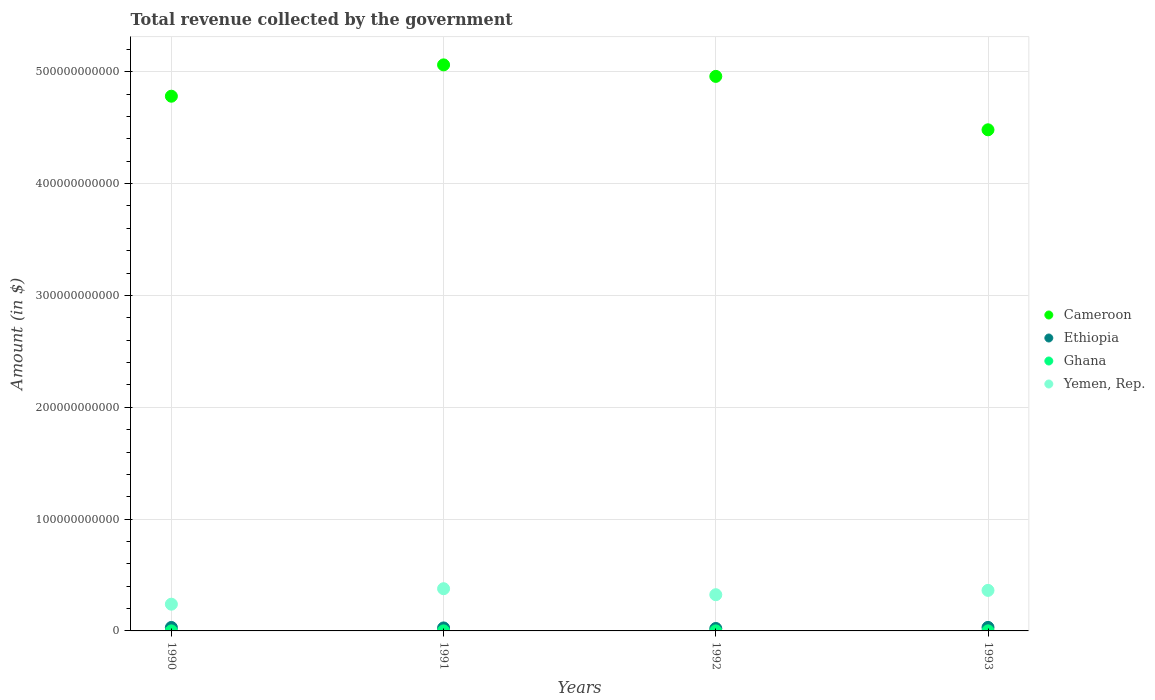How many different coloured dotlines are there?
Your response must be concise. 4. Is the number of dotlines equal to the number of legend labels?
Provide a succinct answer. Yes. What is the total revenue collected by the government in Ethiopia in 1993?
Keep it short and to the point. 3.15e+09. Across all years, what is the maximum total revenue collected by the government in Ethiopia?
Your answer should be very brief. 3.15e+09. Across all years, what is the minimum total revenue collected by the government in Ethiopia?
Provide a succinct answer. 2.18e+09. In which year was the total revenue collected by the government in Yemen, Rep. minimum?
Make the answer very short. 1990. What is the total total revenue collected by the government in Ghana in the graph?
Your answer should be compact. 1.58e+08. What is the difference between the total revenue collected by the government in Ethiopia in 1992 and that in 1993?
Make the answer very short. -9.67e+08. What is the difference between the total revenue collected by the government in Yemen, Rep. in 1991 and the total revenue collected by the government in Ethiopia in 1992?
Provide a succinct answer. 3.56e+1. What is the average total revenue collected by the government in Cameroon per year?
Make the answer very short. 4.82e+11. In the year 1992, what is the difference between the total revenue collected by the government in Cameroon and total revenue collected by the government in Ethiopia?
Your answer should be compact. 4.94e+11. What is the ratio of the total revenue collected by the government in Yemen, Rep. in 1990 to that in 1992?
Give a very brief answer. 0.74. What is the difference between the highest and the second highest total revenue collected by the government in Ethiopia?
Provide a succinct answer. 5.94e+07. What is the difference between the highest and the lowest total revenue collected by the government in Cameroon?
Offer a very short reply. 5.81e+1. In how many years, is the total revenue collected by the government in Cameroon greater than the average total revenue collected by the government in Cameroon taken over all years?
Make the answer very short. 2. Is the sum of the total revenue collected by the government in Yemen, Rep. in 1992 and 1993 greater than the maximum total revenue collected by the government in Ghana across all years?
Offer a terse response. Yes. Is it the case that in every year, the sum of the total revenue collected by the government in Ethiopia and total revenue collected by the government in Yemen, Rep.  is greater than the total revenue collected by the government in Cameroon?
Make the answer very short. No. Is the total revenue collected by the government in Ghana strictly less than the total revenue collected by the government in Yemen, Rep. over the years?
Your answer should be very brief. Yes. What is the difference between two consecutive major ticks on the Y-axis?
Provide a succinct answer. 1.00e+11. Are the values on the major ticks of Y-axis written in scientific E-notation?
Offer a very short reply. No. Does the graph contain any zero values?
Offer a terse response. No. How many legend labels are there?
Offer a very short reply. 4. What is the title of the graph?
Your answer should be very brief. Total revenue collected by the government. Does "Middle East & North Africa (all income levels)" appear as one of the legend labels in the graph?
Provide a short and direct response. No. What is the label or title of the X-axis?
Offer a very short reply. Years. What is the label or title of the Y-axis?
Your answer should be compact. Amount (in $). What is the Amount (in $) in Cameroon in 1990?
Keep it short and to the point. 4.78e+11. What is the Amount (in $) in Ethiopia in 1990?
Ensure brevity in your answer.  3.09e+09. What is the Amount (in $) in Ghana in 1990?
Offer a terse response. 2.40e+07. What is the Amount (in $) in Yemen, Rep. in 1990?
Your response must be concise. 2.39e+1. What is the Amount (in $) of Cameroon in 1991?
Provide a short and direct response. 5.06e+11. What is the Amount (in $) of Ethiopia in 1991?
Give a very brief answer. 2.67e+09. What is the Amount (in $) of Ghana in 1991?
Offer a very short reply. 3.54e+07. What is the Amount (in $) in Yemen, Rep. in 1991?
Offer a very short reply. 3.77e+1. What is the Amount (in $) of Cameroon in 1992?
Keep it short and to the point. 4.96e+11. What is the Amount (in $) of Ethiopia in 1992?
Your answer should be compact. 2.18e+09. What is the Amount (in $) in Ghana in 1992?
Offer a very short reply. 3.34e+07. What is the Amount (in $) in Yemen, Rep. in 1992?
Keep it short and to the point. 3.24e+1. What is the Amount (in $) of Cameroon in 1993?
Provide a succinct answer. 4.48e+11. What is the Amount (in $) in Ethiopia in 1993?
Give a very brief answer. 3.15e+09. What is the Amount (in $) in Ghana in 1993?
Offer a very short reply. 6.58e+07. What is the Amount (in $) in Yemen, Rep. in 1993?
Provide a succinct answer. 3.63e+1. Across all years, what is the maximum Amount (in $) of Cameroon?
Keep it short and to the point. 5.06e+11. Across all years, what is the maximum Amount (in $) of Ethiopia?
Keep it short and to the point. 3.15e+09. Across all years, what is the maximum Amount (in $) of Ghana?
Your answer should be compact. 6.58e+07. Across all years, what is the maximum Amount (in $) in Yemen, Rep.?
Your response must be concise. 3.77e+1. Across all years, what is the minimum Amount (in $) in Cameroon?
Give a very brief answer. 4.48e+11. Across all years, what is the minimum Amount (in $) of Ethiopia?
Provide a succinct answer. 2.18e+09. Across all years, what is the minimum Amount (in $) of Ghana?
Offer a terse response. 2.40e+07. Across all years, what is the minimum Amount (in $) in Yemen, Rep.?
Provide a short and direct response. 2.39e+1. What is the total Amount (in $) in Cameroon in the graph?
Provide a short and direct response. 1.93e+12. What is the total Amount (in $) of Ethiopia in the graph?
Ensure brevity in your answer.  1.11e+1. What is the total Amount (in $) of Ghana in the graph?
Give a very brief answer. 1.58e+08. What is the total Amount (in $) of Yemen, Rep. in the graph?
Offer a very short reply. 1.30e+11. What is the difference between the Amount (in $) in Cameroon in 1990 and that in 1991?
Ensure brevity in your answer.  -2.80e+1. What is the difference between the Amount (in $) in Ethiopia in 1990 and that in 1991?
Provide a short and direct response. 4.22e+08. What is the difference between the Amount (in $) of Ghana in 1990 and that in 1991?
Offer a terse response. -1.15e+07. What is the difference between the Amount (in $) of Yemen, Rep. in 1990 and that in 1991?
Give a very brief answer. -1.38e+1. What is the difference between the Amount (in $) in Cameroon in 1990 and that in 1992?
Offer a very short reply. -1.77e+1. What is the difference between the Amount (in $) of Ethiopia in 1990 and that in 1992?
Your response must be concise. 9.08e+08. What is the difference between the Amount (in $) of Ghana in 1990 and that in 1992?
Give a very brief answer. -9.41e+06. What is the difference between the Amount (in $) in Yemen, Rep. in 1990 and that in 1992?
Your response must be concise. -8.48e+09. What is the difference between the Amount (in $) in Cameroon in 1990 and that in 1993?
Offer a terse response. 3.00e+1. What is the difference between the Amount (in $) of Ethiopia in 1990 and that in 1993?
Give a very brief answer. -5.94e+07. What is the difference between the Amount (in $) in Ghana in 1990 and that in 1993?
Your answer should be compact. -4.18e+07. What is the difference between the Amount (in $) in Yemen, Rep. in 1990 and that in 1993?
Ensure brevity in your answer.  -1.23e+1. What is the difference between the Amount (in $) of Cameroon in 1991 and that in 1992?
Your answer should be compact. 1.03e+1. What is the difference between the Amount (in $) of Ethiopia in 1991 and that in 1992?
Make the answer very short. 4.86e+08. What is the difference between the Amount (in $) of Ghana in 1991 and that in 1992?
Provide a succinct answer. 2.08e+06. What is the difference between the Amount (in $) of Yemen, Rep. in 1991 and that in 1992?
Ensure brevity in your answer.  5.37e+09. What is the difference between the Amount (in $) of Cameroon in 1991 and that in 1993?
Make the answer very short. 5.81e+1. What is the difference between the Amount (in $) of Ethiopia in 1991 and that in 1993?
Keep it short and to the point. -4.81e+08. What is the difference between the Amount (in $) in Ghana in 1991 and that in 1993?
Your response must be concise. -3.03e+07. What is the difference between the Amount (in $) in Yemen, Rep. in 1991 and that in 1993?
Offer a terse response. 1.50e+09. What is the difference between the Amount (in $) of Cameroon in 1992 and that in 1993?
Offer a terse response. 4.78e+1. What is the difference between the Amount (in $) of Ethiopia in 1992 and that in 1993?
Keep it short and to the point. -9.67e+08. What is the difference between the Amount (in $) in Ghana in 1992 and that in 1993?
Offer a terse response. -3.24e+07. What is the difference between the Amount (in $) of Yemen, Rep. in 1992 and that in 1993?
Your answer should be compact. -3.87e+09. What is the difference between the Amount (in $) in Cameroon in 1990 and the Amount (in $) in Ethiopia in 1991?
Give a very brief answer. 4.76e+11. What is the difference between the Amount (in $) in Cameroon in 1990 and the Amount (in $) in Ghana in 1991?
Provide a short and direct response. 4.78e+11. What is the difference between the Amount (in $) in Cameroon in 1990 and the Amount (in $) in Yemen, Rep. in 1991?
Provide a short and direct response. 4.40e+11. What is the difference between the Amount (in $) in Ethiopia in 1990 and the Amount (in $) in Ghana in 1991?
Offer a terse response. 3.06e+09. What is the difference between the Amount (in $) in Ethiopia in 1990 and the Amount (in $) in Yemen, Rep. in 1991?
Offer a very short reply. -3.47e+1. What is the difference between the Amount (in $) of Ghana in 1990 and the Amount (in $) of Yemen, Rep. in 1991?
Provide a succinct answer. -3.77e+1. What is the difference between the Amount (in $) in Cameroon in 1990 and the Amount (in $) in Ethiopia in 1992?
Offer a terse response. 4.76e+11. What is the difference between the Amount (in $) in Cameroon in 1990 and the Amount (in $) in Ghana in 1992?
Make the answer very short. 4.78e+11. What is the difference between the Amount (in $) in Cameroon in 1990 and the Amount (in $) in Yemen, Rep. in 1992?
Ensure brevity in your answer.  4.46e+11. What is the difference between the Amount (in $) of Ethiopia in 1990 and the Amount (in $) of Ghana in 1992?
Ensure brevity in your answer.  3.06e+09. What is the difference between the Amount (in $) in Ethiopia in 1990 and the Amount (in $) in Yemen, Rep. in 1992?
Provide a short and direct response. -2.93e+1. What is the difference between the Amount (in $) in Ghana in 1990 and the Amount (in $) in Yemen, Rep. in 1992?
Ensure brevity in your answer.  -3.24e+1. What is the difference between the Amount (in $) in Cameroon in 1990 and the Amount (in $) in Ethiopia in 1993?
Your answer should be very brief. 4.75e+11. What is the difference between the Amount (in $) in Cameroon in 1990 and the Amount (in $) in Ghana in 1993?
Give a very brief answer. 4.78e+11. What is the difference between the Amount (in $) in Cameroon in 1990 and the Amount (in $) in Yemen, Rep. in 1993?
Offer a very short reply. 4.42e+11. What is the difference between the Amount (in $) in Ethiopia in 1990 and the Amount (in $) in Ghana in 1993?
Make the answer very short. 3.03e+09. What is the difference between the Amount (in $) of Ethiopia in 1990 and the Amount (in $) of Yemen, Rep. in 1993?
Your answer should be very brief. -3.32e+1. What is the difference between the Amount (in $) in Ghana in 1990 and the Amount (in $) in Yemen, Rep. in 1993?
Keep it short and to the point. -3.62e+1. What is the difference between the Amount (in $) in Cameroon in 1991 and the Amount (in $) in Ethiopia in 1992?
Provide a succinct answer. 5.04e+11. What is the difference between the Amount (in $) of Cameroon in 1991 and the Amount (in $) of Ghana in 1992?
Your answer should be compact. 5.06e+11. What is the difference between the Amount (in $) of Cameroon in 1991 and the Amount (in $) of Yemen, Rep. in 1992?
Give a very brief answer. 4.74e+11. What is the difference between the Amount (in $) in Ethiopia in 1991 and the Amount (in $) in Ghana in 1992?
Make the answer very short. 2.64e+09. What is the difference between the Amount (in $) of Ethiopia in 1991 and the Amount (in $) of Yemen, Rep. in 1992?
Offer a very short reply. -2.97e+1. What is the difference between the Amount (in $) in Ghana in 1991 and the Amount (in $) in Yemen, Rep. in 1992?
Ensure brevity in your answer.  -3.23e+1. What is the difference between the Amount (in $) of Cameroon in 1991 and the Amount (in $) of Ethiopia in 1993?
Offer a terse response. 5.03e+11. What is the difference between the Amount (in $) in Cameroon in 1991 and the Amount (in $) in Ghana in 1993?
Your response must be concise. 5.06e+11. What is the difference between the Amount (in $) in Cameroon in 1991 and the Amount (in $) in Yemen, Rep. in 1993?
Provide a short and direct response. 4.70e+11. What is the difference between the Amount (in $) of Ethiopia in 1991 and the Amount (in $) of Ghana in 1993?
Your response must be concise. 2.60e+09. What is the difference between the Amount (in $) of Ethiopia in 1991 and the Amount (in $) of Yemen, Rep. in 1993?
Provide a short and direct response. -3.36e+1. What is the difference between the Amount (in $) in Ghana in 1991 and the Amount (in $) in Yemen, Rep. in 1993?
Provide a short and direct response. -3.62e+1. What is the difference between the Amount (in $) in Cameroon in 1992 and the Amount (in $) in Ethiopia in 1993?
Offer a terse response. 4.93e+11. What is the difference between the Amount (in $) in Cameroon in 1992 and the Amount (in $) in Ghana in 1993?
Offer a very short reply. 4.96e+11. What is the difference between the Amount (in $) of Cameroon in 1992 and the Amount (in $) of Yemen, Rep. in 1993?
Your answer should be very brief. 4.60e+11. What is the difference between the Amount (in $) in Ethiopia in 1992 and the Amount (in $) in Ghana in 1993?
Provide a short and direct response. 2.12e+09. What is the difference between the Amount (in $) in Ethiopia in 1992 and the Amount (in $) in Yemen, Rep. in 1993?
Your answer should be very brief. -3.41e+1. What is the difference between the Amount (in $) in Ghana in 1992 and the Amount (in $) in Yemen, Rep. in 1993?
Provide a short and direct response. -3.62e+1. What is the average Amount (in $) of Cameroon per year?
Provide a succinct answer. 4.82e+11. What is the average Amount (in $) of Ethiopia per year?
Offer a terse response. 2.77e+09. What is the average Amount (in $) in Ghana per year?
Your answer should be compact. 3.96e+07. What is the average Amount (in $) of Yemen, Rep. per year?
Ensure brevity in your answer.  3.26e+1. In the year 1990, what is the difference between the Amount (in $) in Cameroon and Amount (in $) in Ethiopia?
Offer a terse response. 4.75e+11. In the year 1990, what is the difference between the Amount (in $) of Cameroon and Amount (in $) of Ghana?
Provide a succinct answer. 4.78e+11. In the year 1990, what is the difference between the Amount (in $) in Cameroon and Amount (in $) in Yemen, Rep.?
Give a very brief answer. 4.54e+11. In the year 1990, what is the difference between the Amount (in $) in Ethiopia and Amount (in $) in Ghana?
Offer a terse response. 3.07e+09. In the year 1990, what is the difference between the Amount (in $) of Ethiopia and Amount (in $) of Yemen, Rep.?
Your answer should be very brief. -2.08e+1. In the year 1990, what is the difference between the Amount (in $) of Ghana and Amount (in $) of Yemen, Rep.?
Your answer should be very brief. -2.39e+1. In the year 1991, what is the difference between the Amount (in $) in Cameroon and Amount (in $) in Ethiopia?
Keep it short and to the point. 5.04e+11. In the year 1991, what is the difference between the Amount (in $) in Cameroon and Amount (in $) in Ghana?
Your answer should be compact. 5.06e+11. In the year 1991, what is the difference between the Amount (in $) in Cameroon and Amount (in $) in Yemen, Rep.?
Provide a short and direct response. 4.68e+11. In the year 1991, what is the difference between the Amount (in $) of Ethiopia and Amount (in $) of Ghana?
Offer a very short reply. 2.63e+09. In the year 1991, what is the difference between the Amount (in $) of Ethiopia and Amount (in $) of Yemen, Rep.?
Keep it short and to the point. -3.51e+1. In the year 1991, what is the difference between the Amount (in $) in Ghana and Amount (in $) in Yemen, Rep.?
Provide a short and direct response. -3.77e+1. In the year 1992, what is the difference between the Amount (in $) in Cameroon and Amount (in $) in Ethiopia?
Keep it short and to the point. 4.94e+11. In the year 1992, what is the difference between the Amount (in $) of Cameroon and Amount (in $) of Ghana?
Provide a succinct answer. 4.96e+11. In the year 1992, what is the difference between the Amount (in $) in Cameroon and Amount (in $) in Yemen, Rep.?
Make the answer very short. 4.64e+11. In the year 1992, what is the difference between the Amount (in $) of Ethiopia and Amount (in $) of Ghana?
Your response must be concise. 2.15e+09. In the year 1992, what is the difference between the Amount (in $) in Ethiopia and Amount (in $) in Yemen, Rep.?
Your answer should be very brief. -3.02e+1. In the year 1992, what is the difference between the Amount (in $) of Ghana and Amount (in $) of Yemen, Rep.?
Give a very brief answer. -3.23e+1. In the year 1993, what is the difference between the Amount (in $) in Cameroon and Amount (in $) in Ethiopia?
Keep it short and to the point. 4.45e+11. In the year 1993, what is the difference between the Amount (in $) of Cameroon and Amount (in $) of Ghana?
Ensure brevity in your answer.  4.48e+11. In the year 1993, what is the difference between the Amount (in $) of Cameroon and Amount (in $) of Yemen, Rep.?
Provide a succinct answer. 4.12e+11. In the year 1993, what is the difference between the Amount (in $) of Ethiopia and Amount (in $) of Ghana?
Your response must be concise. 3.08e+09. In the year 1993, what is the difference between the Amount (in $) in Ethiopia and Amount (in $) in Yemen, Rep.?
Provide a short and direct response. -3.31e+1. In the year 1993, what is the difference between the Amount (in $) in Ghana and Amount (in $) in Yemen, Rep.?
Give a very brief answer. -3.62e+1. What is the ratio of the Amount (in $) of Cameroon in 1990 to that in 1991?
Keep it short and to the point. 0.94. What is the ratio of the Amount (in $) of Ethiopia in 1990 to that in 1991?
Offer a terse response. 1.16. What is the ratio of the Amount (in $) of Ghana in 1990 to that in 1991?
Ensure brevity in your answer.  0.68. What is the ratio of the Amount (in $) of Yemen, Rep. in 1990 to that in 1991?
Your answer should be very brief. 0.63. What is the ratio of the Amount (in $) in Cameroon in 1990 to that in 1992?
Keep it short and to the point. 0.96. What is the ratio of the Amount (in $) of Ethiopia in 1990 to that in 1992?
Provide a short and direct response. 1.42. What is the ratio of the Amount (in $) of Ghana in 1990 to that in 1992?
Offer a terse response. 0.72. What is the ratio of the Amount (in $) of Yemen, Rep. in 1990 to that in 1992?
Offer a terse response. 0.74. What is the ratio of the Amount (in $) of Cameroon in 1990 to that in 1993?
Your answer should be very brief. 1.07. What is the ratio of the Amount (in $) in Ethiopia in 1990 to that in 1993?
Give a very brief answer. 0.98. What is the ratio of the Amount (in $) of Ghana in 1990 to that in 1993?
Ensure brevity in your answer.  0.36. What is the ratio of the Amount (in $) of Yemen, Rep. in 1990 to that in 1993?
Offer a very short reply. 0.66. What is the ratio of the Amount (in $) of Cameroon in 1991 to that in 1992?
Your answer should be very brief. 1.02. What is the ratio of the Amount (in $) of Ethiopia in 1991 to that in 1992?
Keep it short and to the point. 1.22. What is the ratio of the Amount (in $) in Ghana in 1991 to that in 1992?
Your answer should be very brief. 1.06. What is the ratio of the Amount (in $) in Yemen, Rep. in 1991 to that in 1992?
Your answer should be compact. 1.17. What is the ratio of the Amount (in $) in Cameroon in 1991 to that in 1993?
Provide a succinct answer. 1.13. What is the ratio of the Amount (in $) in Ethiopia in 1991 to that in 1993?
Give a very brief answer. 0.85. What is the ratio of the Amount (in $) of Ghana in 1991 to that in 1993?
Make the answer very short. 0.54. What is the ratio of the Amount (in $) in Yemen, Rep. in 1991 to that in 1993?
Provide a short and direct response. 1.04. What is the ratio of the Amount (in $) of Cameroon in 1992 to that in 1993?
Your response must be concise. 1.11. What is the ratio of the Amount (in $) of Ethiopia in 1992 to that in 1993?
Provide a succinct answer. 0.69. What is the ratio of the Amount (in $) in Ghana in 1992 to that in 1993?
Make the answer very short. 0.51. What is the ratio of the Amount (in $) of Yemen, Rep. in 1992 to that in 1993?
Give a very brief answer. 0.89. What is the difference between the highest and the second highest Amount (in $) of Cameroon?
Your response must be concise. 1.03e+1. What is the difference between the highest and the second highest Amount (in $) of Ethiopia?
Offer a terse response. 5.94e+07. What is the difference between the highest and the second highest Amount (in $) of Ghana?
Ensure brevity in your answer.  3.03e+07. What is the difference between the highest and the second highest Amount (in $) of Yemen, Rep.?
Offer a very short reply. 1.50e+09. What is the difference between the highest and the lowest Amount (in $) of Cameroon?
Give a very brief answer. 5.81e+1. What is the difference between the highest and the lowest Amount (in $) in Ethiopia?
Give a very brief answer. 9.67e+08. What is the difference between the highest and the lowest Amount (in $) of Ghana?
Provide a short and direct response. 4.18e+07. What is the difference between the highest and the lowest Amount (in $) of Yemen, Rep.?
Provide a short and direct response. 1.38e+1. 